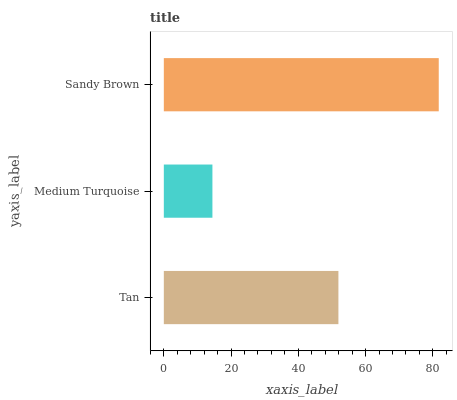Is Medium Turquoise the minimum?
Answer yes or no. Yes. Is Sandy Brown the maximum?
Answer yes or no. Yes. Is Sandy Brown the minimum?
Answer yes or no. No. Is Medium Turquoise the maximum?
Answer yes or no. No. Is Sandy Brown greater than Medium Turquoise?
Answer yes or no. Yes. Is Medium Turquoise less than Sandy Brown?
Answer yes or no. Yes. Is Medium Turquoise greater than Sandy Brown?
Answer yes or no. No. Is Sandy Brown less than Medium Turquoise?
Answer yes or no. No. Is Tan the high median?
Answer yes or no. Yes. Is Tan the low median?
Answer yes or no. Yes. Is Medium Turquoise the high median?
Answer yes or no. No. Is Sandy Brown the low median?
Answer yes or no. No. 